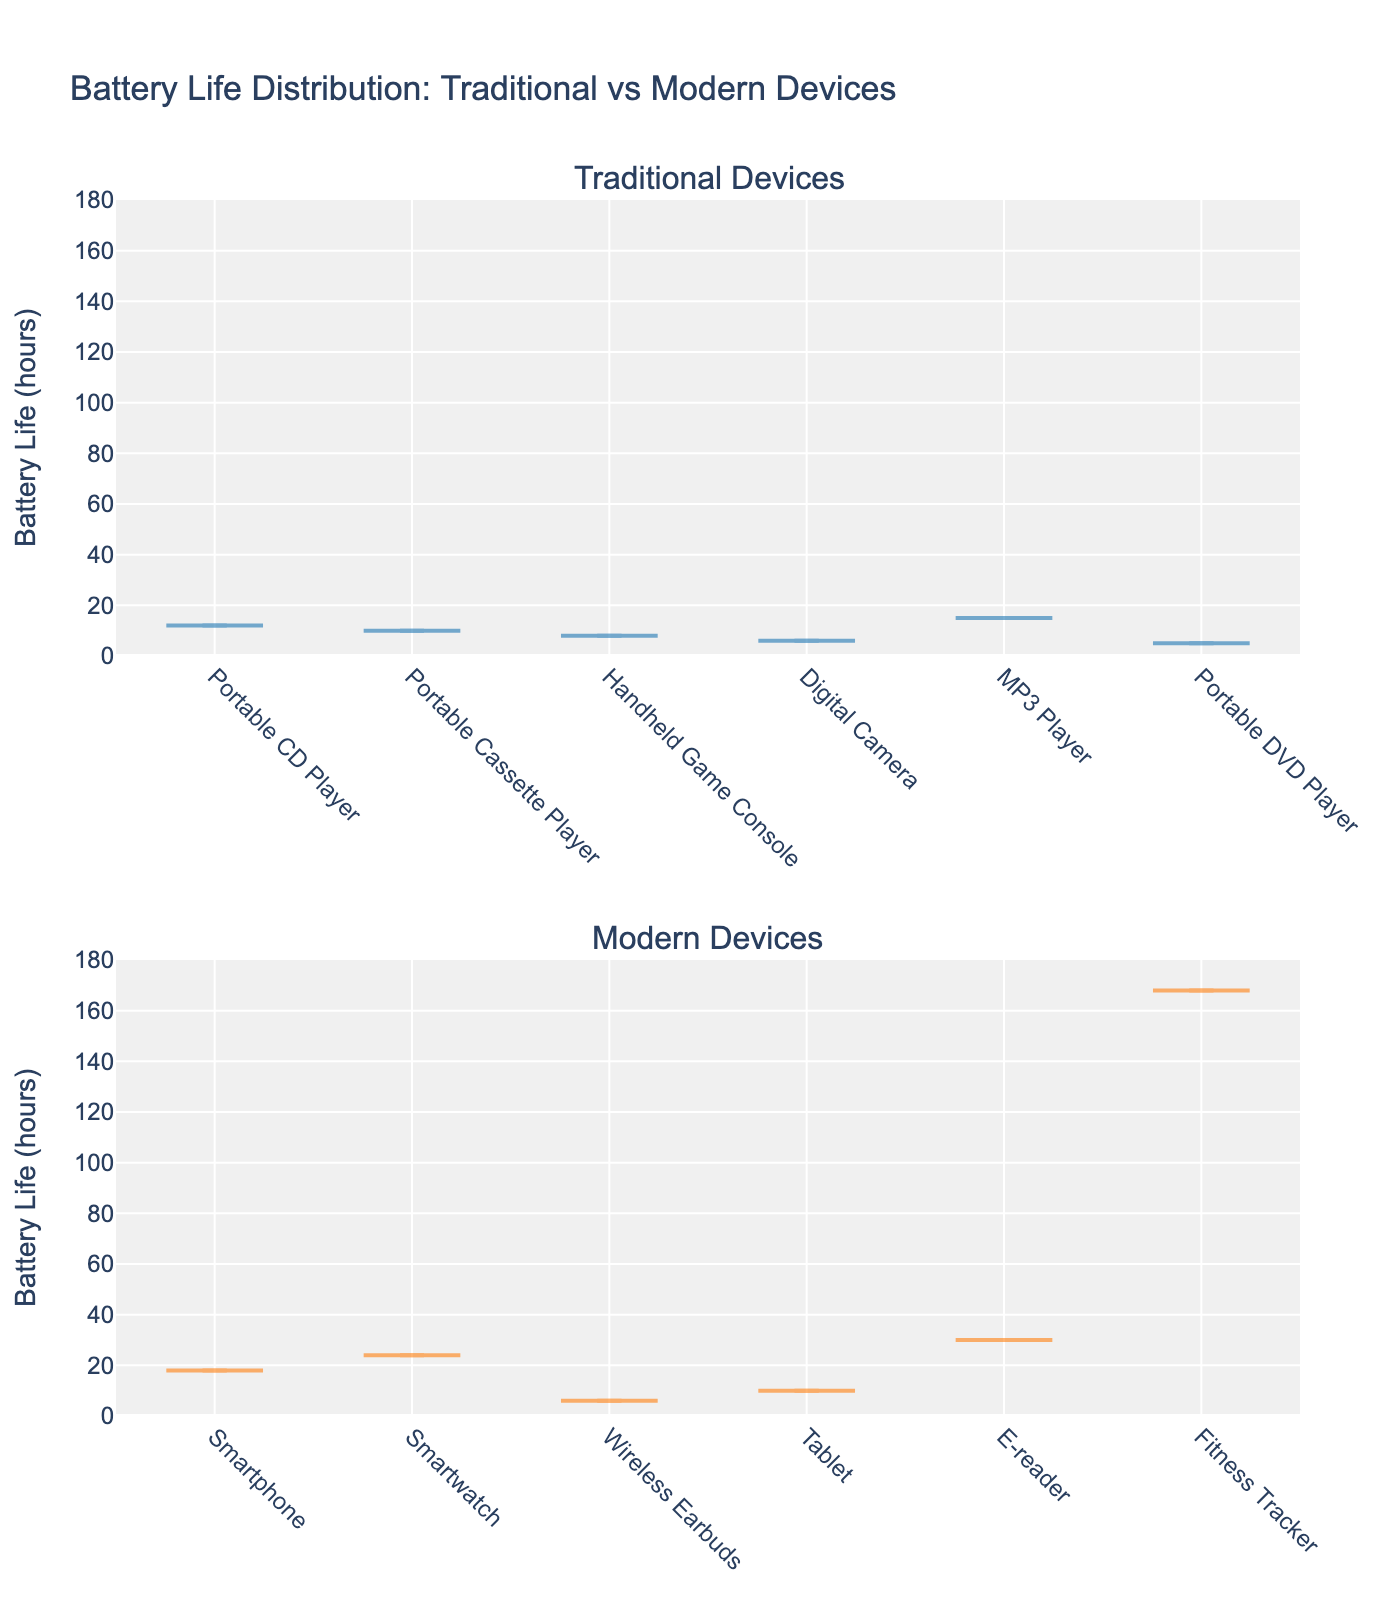What's the title of the figure? The title of the figure appears at the top and is intended to summarize the main focus of the plot
Answer: Battery Life Distribution: Traditional vs Modern Devices What does the y-axis represent in the figure? The y-axis is labeled and typically represents the variable being measured in the plot
Answer: Battery Life (hours) Which modern device has the highest battery life? By looking at the violin plot of modern devices, we can identify the one with the highest point in battery life
Answer: Fitness Tracker Which traditional device has the lowest battery life? By examining the violin plot of traditional devices, we can spot the device with the lowest battery life value
Answer: Portable DVD Player How do the average battery lives of traditional and modern devices compare? Calculate and compare the average battery life for devices in each category. Sum all battery life values in each group and divide by the number of devices in that group to find the averages
Answer: The average battery life of modern devices is higher Which category shows more variation in battery life, traditional or modern devices? Assessing the distribution spread (width of violin plots) for traditional and modern devices will indicate which category has more variation
Answer: Modern devices show more variation Are there any devices in both categories that have the same battery life? By looking at the overlapping points in the violin plots of both traditional and modern devices, we can determine if any devices share the same battery life
Answer: Digital Camera (Traditional) and Wireless Earbuds (Modern) both have 6 hours of battery life Does the maximum battery life of any modern device exceed 100 hours? By checking the y-axis range and the plotted values for modern devices, we can see if any points go beyond 100 hours
Answer: Yes, the Fitness Tracker What is the range of battery life values for traditional devices? Identify the lowest and highest battery life values shown by the violin plot for traditional devices
Answer: The range is 5 to 15 hours What's the median battery life of modern devices? The median value is the middle value when the devices' battery lives are ordered. Visualize the violin plot to roughly estimate where the median lies or use statistical calculations
Answer: Approximately 24 hours 